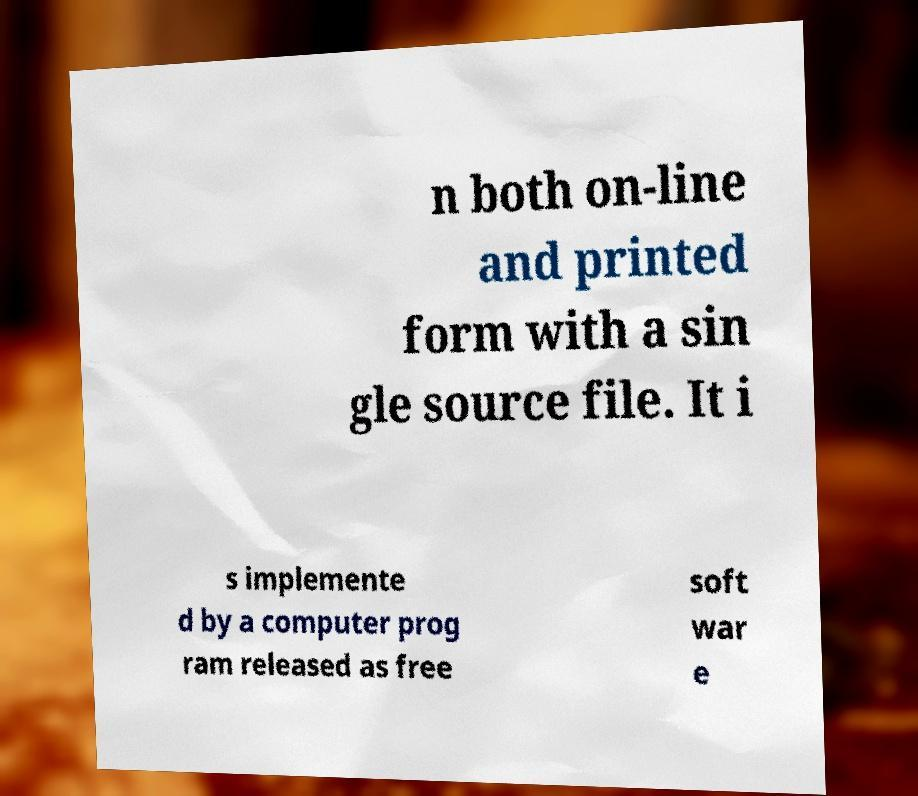Please identify and transcribe the text found in this image. n both on-line and printed form with a sin gle source file. It i s implemente d by a computer prog ram released as free soft war e 